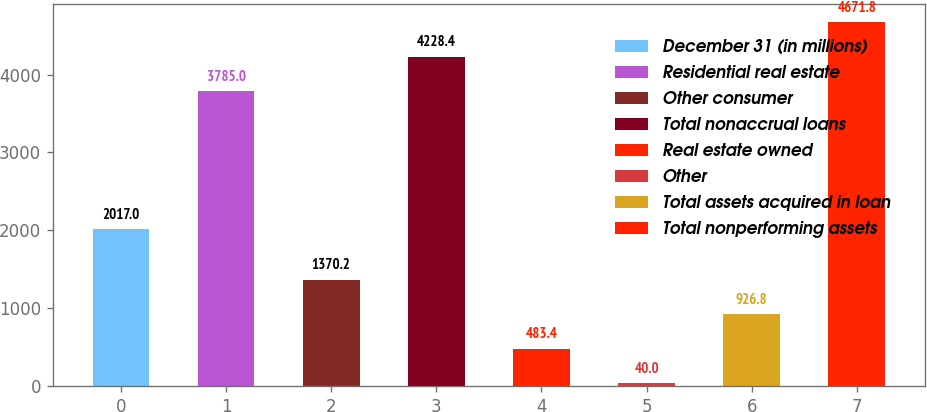<chart> <loc_0><loc_0><loc_500><loc_500><bar_chart><fcel>December 31 (in millions)<fcel>Residential real estate<fcel>Other consumer<fcel>Total nonaccrual loans<fcel>Real estate owned<fcel>Other<fcel>Total assets acquired in loan<fcel>Total nonperforming assets<nl><fcel>2017<fcel>3785<fcel>1370.2<fcel>4228.4<fcel>483.4<fcel>40<fcel>926.8<fcel>4671.8<nl></chart> 